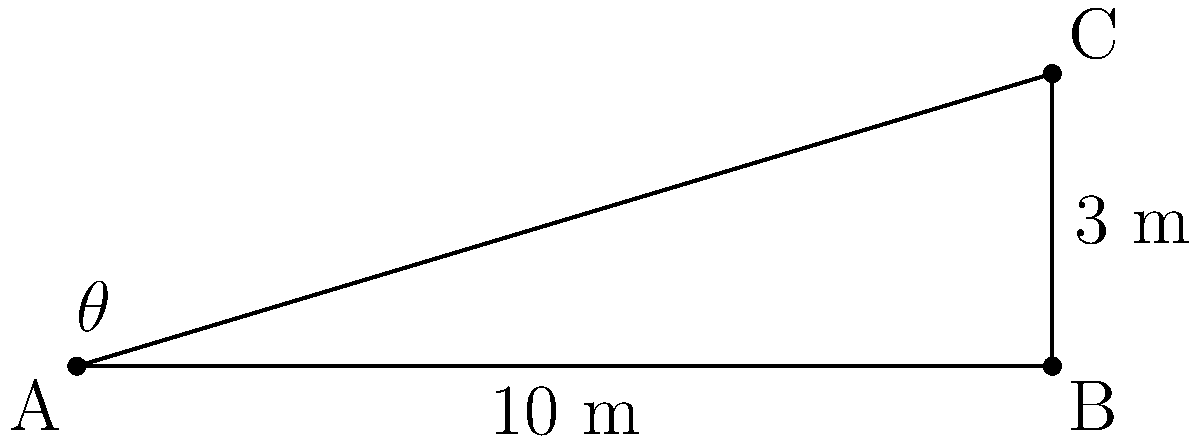As a florist, you're designing a sloped flower bed for a wedding venue. The bed rises 3 meters over a horizontal distance of 10 meters. What is the angle $\theta$ of the slope in degrees? To find the angle of the slope, we can use the inverse tangent function (arctangent or $\tan^{-1}$). Here's how to solve it step-by-step:

1) In a right triangle, $\tan\theta = \frac{\text{opposite}}{\text{adjacent}}$

2) In this case:
   - The rise (opposite side) is 3 meters
   - The run (adjacent side) is 10 meters

3) So, we have: $\tan\theta = \frac{3}{10}$

4) To find $\theta$, we take the inverse tangent of both sides:
   $\theta = \tan^{-1}(\frac{3}{10})$

5) Using a calculator or trigonometric tables:
   $\theta \approx 16.70^\circ$

6) Rounding to the nearest degree:
   $\theta \approx 17^\circ$
Answer: $17^\circ$ 